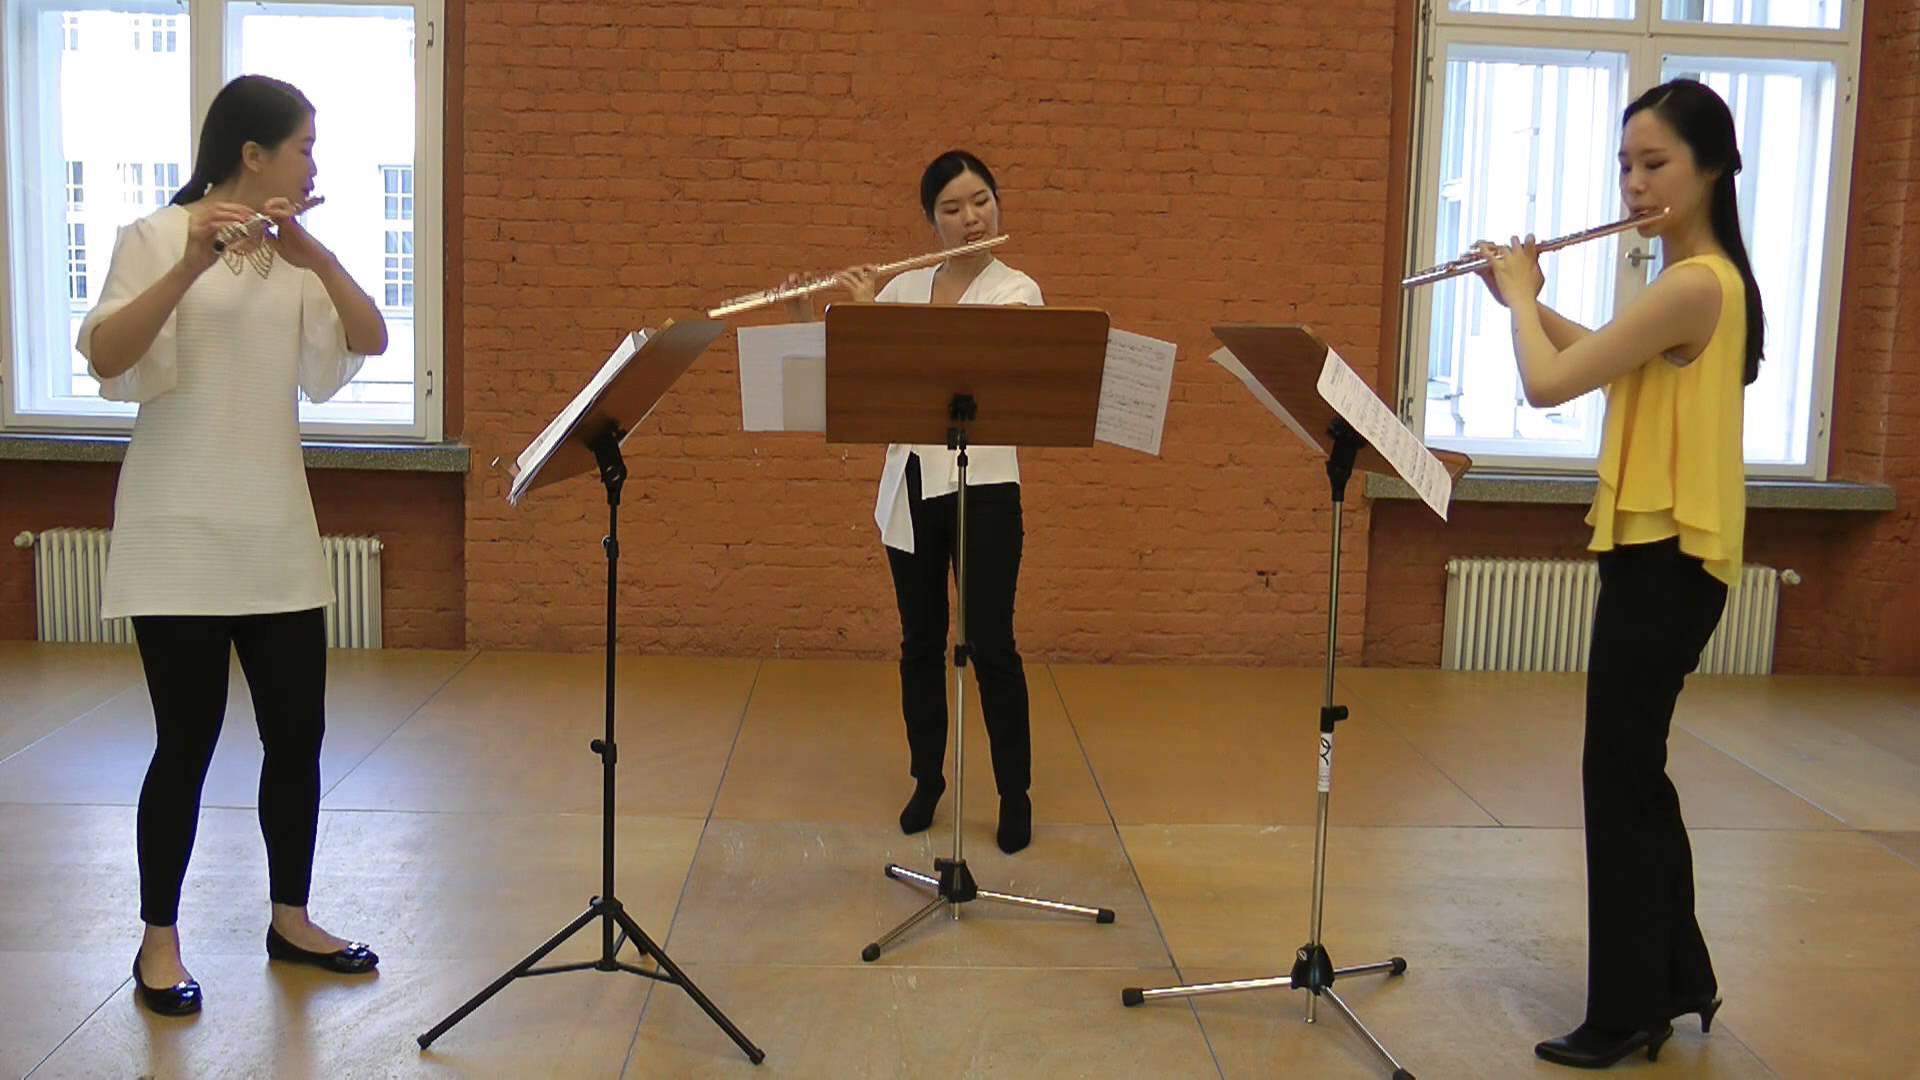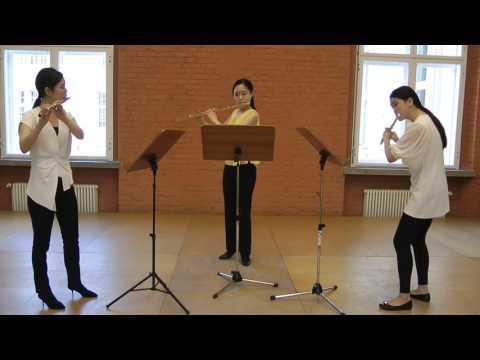The first image is the image on the left, the second image is the image on the right. Evaluate the accuracy of this statement regarding the images: "There are six flutists standing.". Is it true? Answer yes or no. Yes. The first image is the image on the left, the second image is the image on the right. Given the left and right images, does the statement "There are three women in black dresses  looking at sheet music while playing the flute" hold true? Answer yes or no. No. 